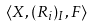Convert formula to latex. <formula><loc_0><loc_0><loc_500><loc_500>\langle X , ( R _ { i } ) _ { I } , F \rangle</formula> 